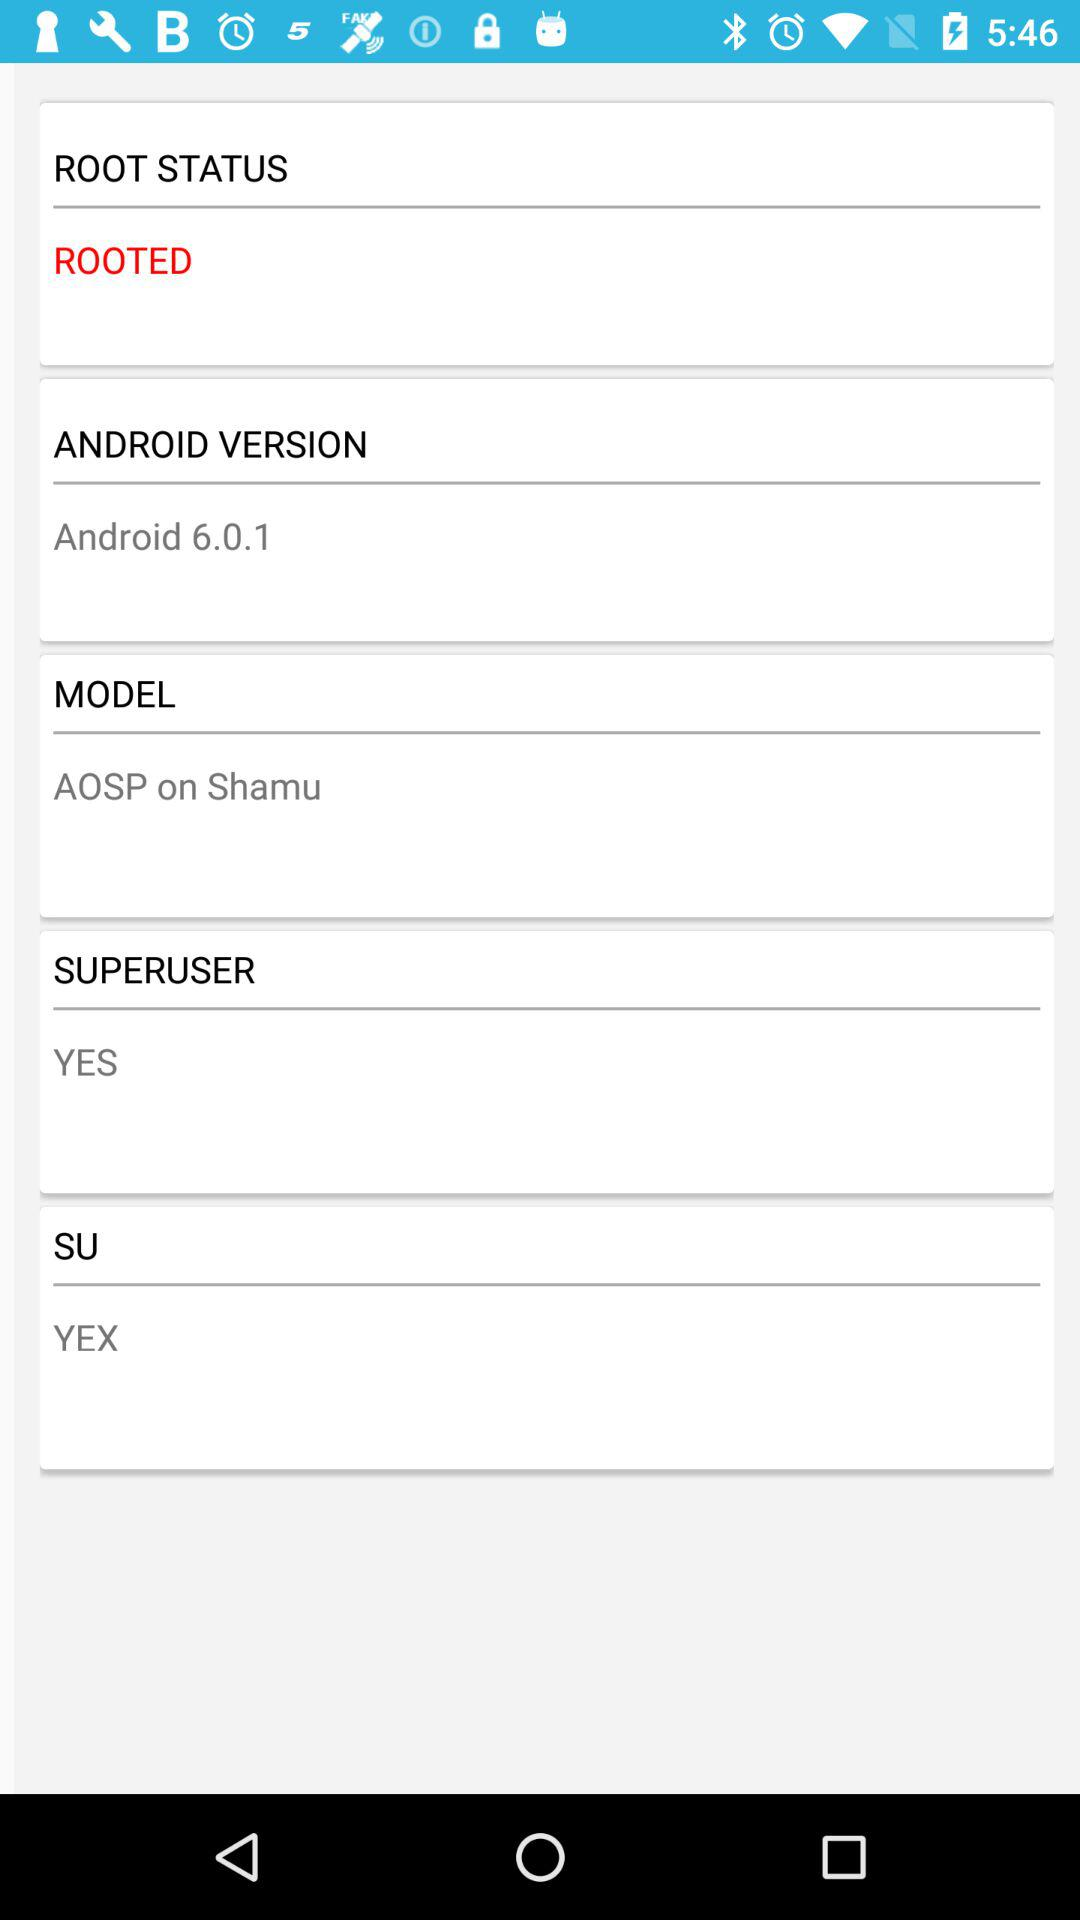What is the root status? The root status is "ROOTED". 